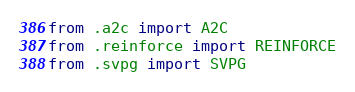<code> <loc_0><loc_0><loc_500><loc_500><_Python_>from .a2c import A2C
from .reinforce import REINFORCE
from .svpg import SVPG
</code> 